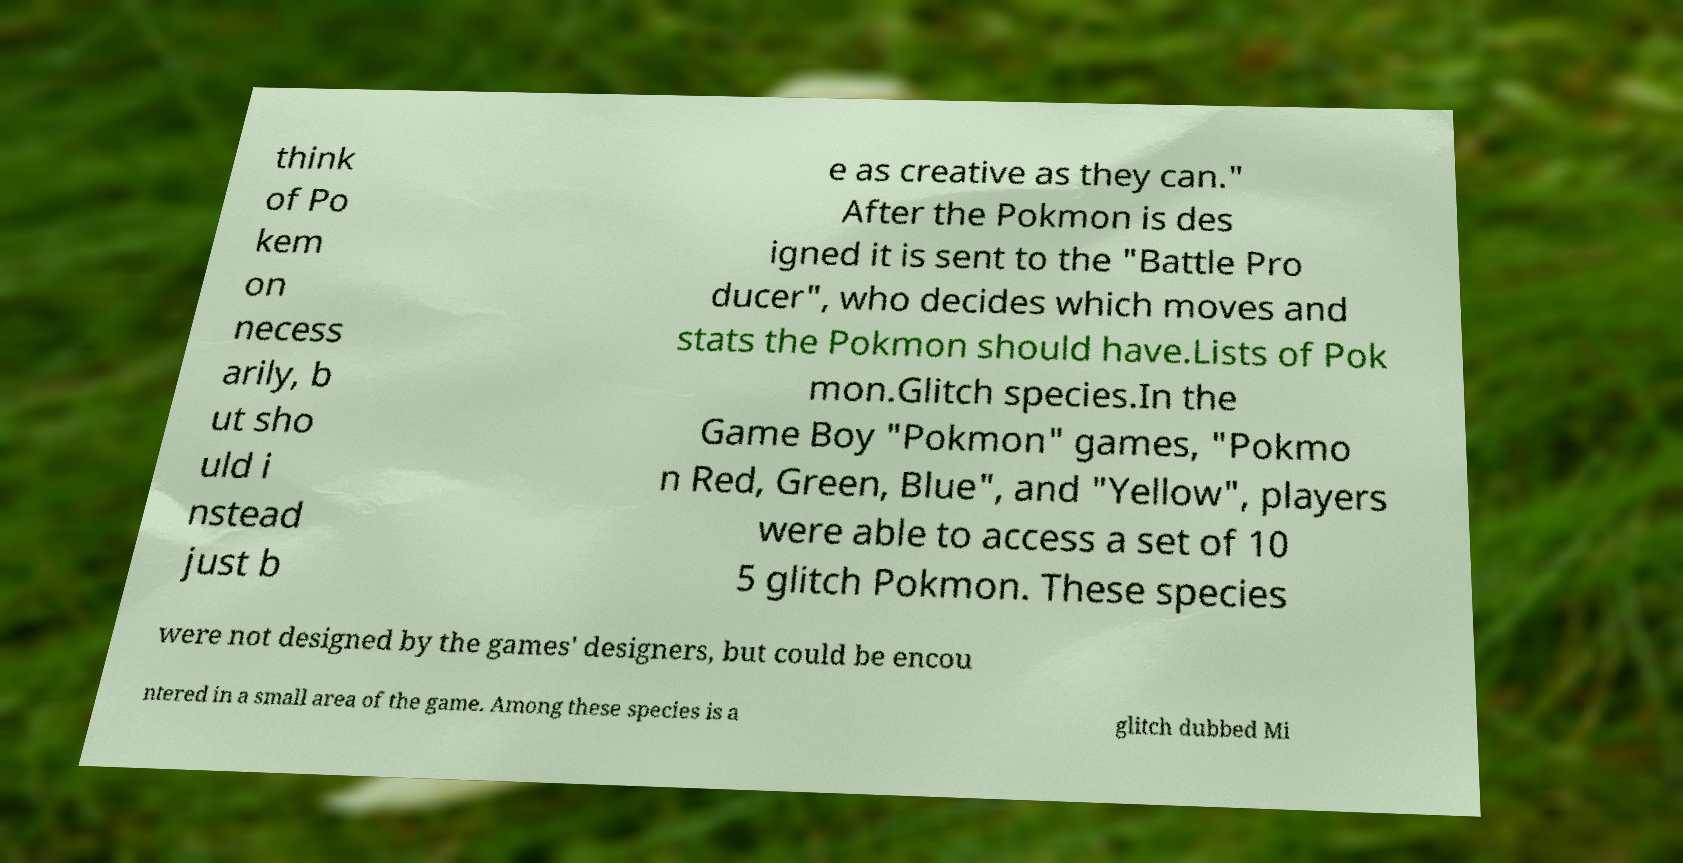There's text embedded in this image that I need extracted. Can you transcribe it verbatim? think of Po kem on necess arily, b ut sho uld i nstead just b e as creative as they can." After the Pokmon is des igned it is sent to the "Battle Pro ducer", who decides which moves and stats the Pokmon should have.Lists of Pok mon.Glitch species.In the Game Boy "Pokmon" games, "Pokmo n Red, Green, Blue", and "Yellow", players were able to access a set of 10 5 glitch Pokmon. These species were not designed by the games' designers, but could be encou ntered in a small area of the game. Among these species is a glitch dubbed Mi 